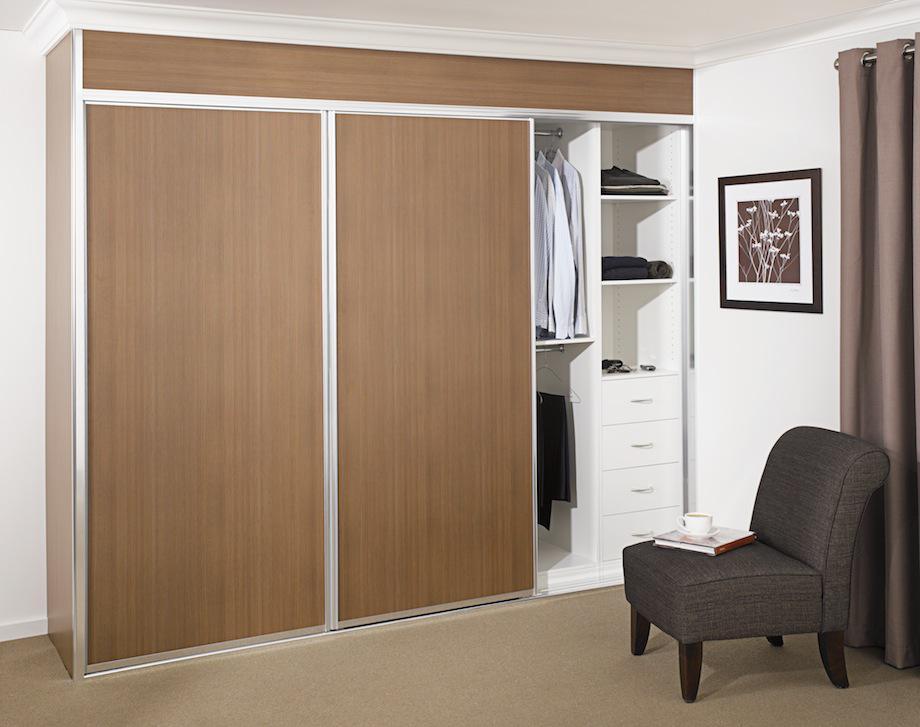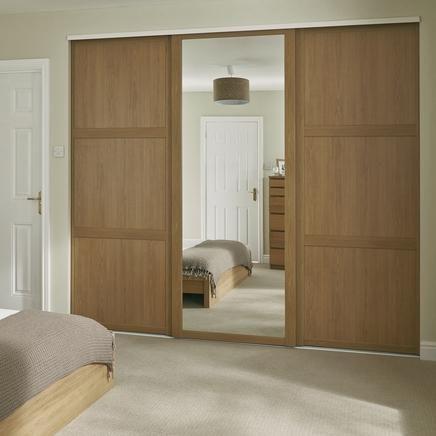The first image is the image on the left, the second image is the image on the right. For the images displayed, is the sentence "In one of the images there are clothes visible inside the partially open closet." factually correct? Answer yes or no. Yes. The first image is the image on the left, the second image is the image on the right. Analyze the images presented: Is the assertion "A rug covers the floor in at least one of the images." valid? Answer yes or no. No. 